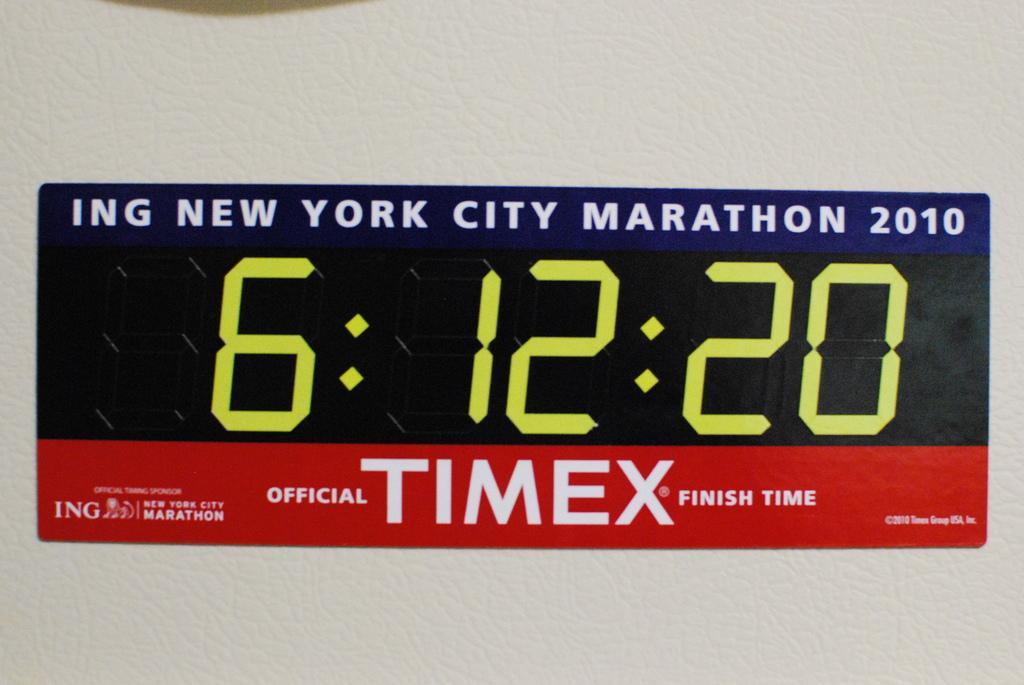Could you give a brief overview of what you see in this image? In this image I see the white surface on which I see a sticker and I see words and numbers on it. 